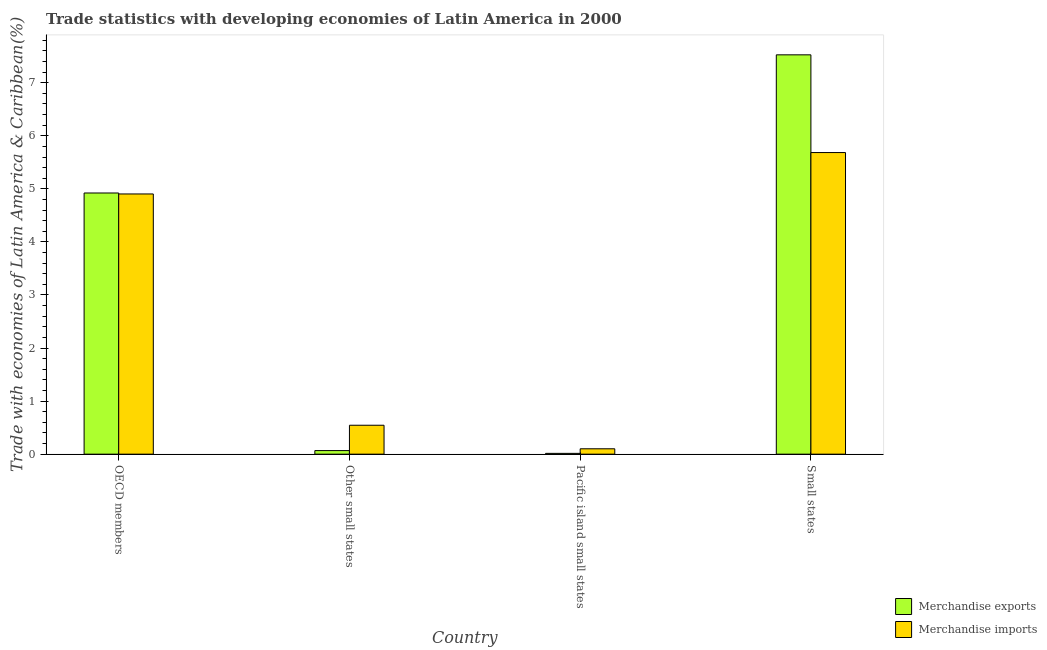How many groups of bars are there?
Your answer should be very brief. 4. Are the number of bars per tick equal to the number of legend labels?
Your answer should be very brief. Yes. What is the label of the 2nd group of bars from the left?
Ensure brevity in your answer.  Other small states. In how many cases, is the number of bars for a given country not equal to the number of legend labels?
Ensure brevity in your answer.  0. What is the merchandise exports in Other small states?
Ensure brevity in your answer.  0.07. Across all countries, what is the maximum merchandise imports?
Ensure brevity in your answer.  5.68. Across all countries, what is the minimum merchandise exports?
Your answer should be compact. 0.02. In which country was the merchandise imports maximum?
Your response must be concise. Small states. In which country was the merchandise imports minimum?
Give a very brief answer. Pacific island small states. What is the total merchandise exports in the graph?
Ensure brevity in your answer.  12.53. What is the difference between the merchandise imports in OECD members and that in Other small states?
Make the answer very short. 4.36. What is the difference between the merchandise exports in Small states and the merchandise imports in Pacific island small states?
Give a very brief answer. 7.42. What is the average merchandise imports per country?
Your answer should be compact. 2.81. What is the difference between the merchandise exports and merchandise imports in Small states?
Your answer should be compact. 1.84. In how many countries, is the merchandise imports greater than 7 %?
Keep it short and to the point. 0. What is the ratio of the merchandise exports in OECD members to that in Other small states?
Offer a very short reply. 72.96. Is the merchandise imports in OECD members less than that in Other small states?
Provide a succinct answer. No. Is the difference between the merchandise exports in Other small states and Small states greater than the difference between the merchandise imports in Other small states and Small states?
Keep it short and to the point. No. What is the difference between the highest and the second highest merchandise exports?
Offer a terse response. 2.6. What is the difference between the highest and the lowest merchandise imports?
Provide a short and direct response. 5.58. What does the 1st bar from the right in OECD members represents?
Your response must be concise. Merchandise imports. How many bars are there?
Offer a terse response. 8. Are all the bars in the graph horizontal?
Your response must be concise. No. How many countries are there in the graph?
Ensure brevity in your answer.  4. Are the values on the major ticks of Y-axis written in scientific E-notation?
Your answer should be compact. No. Does the graph contain any zero values?
Your answer should be very brief. No. Does the graph contain grids?
Ensure brevity in your answer.  No. Where does the legend appear in the graph?
Provide a short and direct response. Bottom right. How many legend labels are there?
Make the answer very short. 2. What is the title of the graph?
Your answer should be compact. Trade statistics with developing economies of Latin America in 2000. Does "Number of departures" appear as one of the legend labels in the graph?
Keep it short and to the point. No. What is the label or title of the Y-axis?
Give a very brief answer. Trade with economies of Latin America & Caribbean(%). What is the Trade with economies of Latin America & Caribbean(%) in Merchandise exports in OECD members?
Your answer should be compact. 4.92. What is the Trade with economies of Latin America & Caribbean(%) of Merchandise imports in OECD members?
Your response must be concise. 4.9. What is the Trade with economies of Latin America & Caribbean(%) of Merchandise exports in Other small states?
Offer a terse response. 0.07. What is the Trade with economies of Latin America & Caribbean(%) of Merchandise imports in Other small states?
Provide a succinct answer. 0.55. What is the Trade with economies of Latin America & Caribbean(%) in Merchandise exports in Pacific island small states?
Give a very brief answer. 0.02. What is the Trade with economies of Latin America & Caribbean(%) of Merchandise imports in Pacific island small states?
Make the answer very short. 0.1. What is the Trade with economies of Latin America & Caribbean(%) in Merchandise exports in Small states?
Your response must be concise. 7.53. What is the Trade with economies of Latin America & Caribbean(%) of Merchandise imports in Small states?
Offer a very short reply. 5.68. Across all countries, what is the maximum Trade with economies of Latin America & Caribbean(%) in Merchandise exports?
Your answer should be very brief. 7.53. Across all countries, what is the maximum Trade with economies of Latin America & Caribbean(%) of Merchandise imports?
Your answer should be compact. 5.68. Across all countries, what is the minimum Trade with economies of Latin America & Caribbean(%) of Merchandise exports?
Give a very brief answer. 0.02. Across all countries, what is the minimum Trade with economies of Latin America & Caribbean(%) of Merchandise imports?
Your answer should be very brief. 0.1. What is the total Trade with economies of Latin America & Caribbean(%) in Merchandise exports in the graph?
Offer a very short reply. 12.53. What is the total Trade with economies of Latin America & Caribbean(%) of Merchandise imports in the graph?
Your answer should be very brief. 11.23. What is the difference between the Trade with economies of Latin America & Caribbean(%) in Merchandise exports in OECD members and that in Other small states?
Your response must be concise. 4.85. What is the difference between the Trade with economies of Latin America & Caribbean(%) of Merchandise imports in OECD members and that in Other small states?
Make the answer very short. 4.36. What is the difference between the Trade with economies of Latin America & Caribbean(%) in Merchandise exports in OECD members and that in Pacific island small states?
Your response must be concise. 4.91. What is the difference between the Trade with economies of Latin America & Caribbean(%) in Merchandise imports in OECD members and that in Pacific island small states?
Your answer should be very brief. 4.8. What is the difference between the Trade with economies of Latin America & Caribbean(%) in Merchandise exports in OECD members and that in Small states?
Ensure brevity in your answer.  -2.6. What is the difference between the Trade with economies of Latin America & Caribbean(%) of Merchandise imports in OECD members and that in Small states?
Provide a short and direct response. -0.78. What is the difference between the Trade with economies of Latin America & Caribbean(%) in Merchandise exports in Other small states and that in Pacific island small states?
Keep it short and to the point. 0.05. What is the difference between the Trade with economies of Latin America & Caribbean(%) of Merchandise imports in Other small states and that in Pacific island small states?
Offer a terse response. 0.44. What is the difference between the Trade with economies of Latin America & Caribbean(%) in Merchandise exports in Other small states and that in Small states?
Keep it short and to the point. -7.46. What is the difference between the Trade with economies of Latin America & Caribbean(%) in Merchandise imports in Other small states and that in Small states?
Your response must be concise. -5.14. What is the difference between the Trade with economies of Latin America & Caribbean(%) of Merchandise exports in Pacific island small states and that in Small states?
Provide a succinct answer. -7.51. What is the difference between the Trade with economies of Latin America & Caribbean(%) of Merchandise imports in Pacific island small states and that in Small states?
Offer a very short reply. -5.58. What is the difference between the Trade with economies of Latin America & Caribbean(%) of Merchandise exports in OECD members and the Trade with economies of Latin America & Caribbean(%) of Merchandise imports in Other small states?
Ensure brevity in your answer.  4.38. What is the difference between the Trade with economies of Latin America & Caribbean(%) in Merchandise exports in OECD members and the Trade with economies of Latin America & Caribbean(%) in Merchandise imports in Pacific island small states?
Provide a short and direct response. 4.82. What is the difference between the Trade with economies of Latin America & Caribbean(%) of Merchandise exports in OECD members and the Trade with economies of Latin America & Caribbean(%) of Merchandise imports in Small states?
Make the answer very short. -0.76. What is the difference between the Trade with economies of Latin America & Caribbean(%) of Merchandise exports in Other small states and the Trade with economies of Latin America & Caribbean(%) of Merchandise imports in Pacific island small states?
Ensure brevity in your answer.  -0.03. What is the difference between the Trade with economies of Latin America & Caribbean(%) of Merchandise exports in Other small states and the Trade with economies of Latin America & Caribbean(%) of Merchandise imports in Small states?
Offer a terse response. -5.62. What is the difference between the Trade with economies of Latin America & Caribbean(%) in Merchandise exports in Pacific island small states and the Trade with economies of Latin America & Caribbean(%) in Merchandise imports in Small states?
Your answer should be very brief. -5.67. What is the average Trade with economies of Latin America & Caribbean(%) in Merchandise exports per country?
Provide a succinct answer. 3.13. What is the average Trade with economies of Latin America & Caribbean(%) in Merchandise imports per country?
Offer a terse response. 2.81. What is the difference between the Trade with economies of Latin America & Caribbean(%) of Merchandise exports and Trade with economies of Latin America & Caribbean(%) of Merchandise imports in OECD members?
Provide a succinct answer. 0.02. What is the difference between the Trade with economies of Latin America & Caribbean(%) in Merchandise exports and Trade with economies of Latin America & Caribbean(%) in Merchandise imports in Other small states?
Provide a succinct answer. -0.48. What is the difference between the Trade with economies of Latin America & Caribbean(%) in Merchandise exports and Trade with economies of Latin America & Caribbean(%) in Merchandise imports in Pacific island small states?
Provide a succinct answer. -0.09. What is the difference between the Trade with economies of Latin America & Caribbean(%) of Merchandise exports and Trade with economies of Latin America & Caribbean(%) of Merchandise imports in Small states?
Provide a short and direct response. 1.84. What is the ratio of the Trade with economies of Latin America & Caribbean(%) in Merchandise exports in OECD members to that in Other small states?
Give a very brief answer. 72.96. What is the ratio of the Trade with economies of Latin America & Caribbean(%) of Merchandise imports in OECD members to that in Other small states?
Offer a very short reply. 9. What is the ratio of the Trade with economies of Latin America & Caribbean(%) in Merchandise exports in OECD members to that in Pacific island small states?
Give a very brief answer. 327.24. What is the ratio of the Trade with economies of Latin America & Caribbean(%) of Merchandise imports in OECD members to that in Pacific island small states?
Offer a very short reply. 48.37. What is the ratio of the Trade with economies of Latin America & Caribbean(%) in Merchandise exports in OECD members to that in Small states?
Give a very brief answer. 0.65. What is the ratio of the Trade with economies of Latin America & Caribbean(%) in Merchandise imports in OECD members to that in Small states?
Offer a terse response. 0.86. What is the ratio of the Trade with economies of Latin America & Caribbean(%) of Merchandise exports in Other small states to that in Pacific island small states?
Offer a very short reply. 4.49. What is the ratio of the Trade with economies of Latin America & Caribbean(%) of Merchandise imports in Other small states to that in Pacific island small states?
Offer a terse response. 5.38. What is the ratio of the Trade with economies of Latin America & Caribbean(%) of Merchandise exports in Other small states to that in Small states?
Your answer should be very brief. 0.01. What is the ratio of the Trade with economies of Latin America & Caribbean(%) in Merchandise imports in Other small states to that in Small states?
Keep it short and to the point. 0.1. What is the ratio of the Trade with economies of Latin America & Caribbean(%) of Merchandise exports in Pacific island small states to that in Small states?
Provide a succinct answer. 0. What is the ratio of the Trade with economies of Latin America & Caribbean(%) in Merchandise imports in Pacific island small states to that in Small states?
Ensure brevity in your answer.  0.02. What is the difference between the highest and the second highest Trade with economies of Latin America & Caribbean(%) of Merchandise exports?
Ensure brevity in your answer.  2.6. What is the difference between the highest and the second highest Trade with economies of Latin America & Caribbean(%) in Merchandise imports?
Your answer should be very brief. 0.78. What is the difference between the highest and the lowest Trade with economies of Latin America & Caribbean(%) of Merchandise exports?
Give a very brief answer. 7.51. What is the difference between the highest and the lowest Trade with economies of Latin America & Caribbean(%) of Merchandise imports?
Provide a succinct answer. 5.58. 